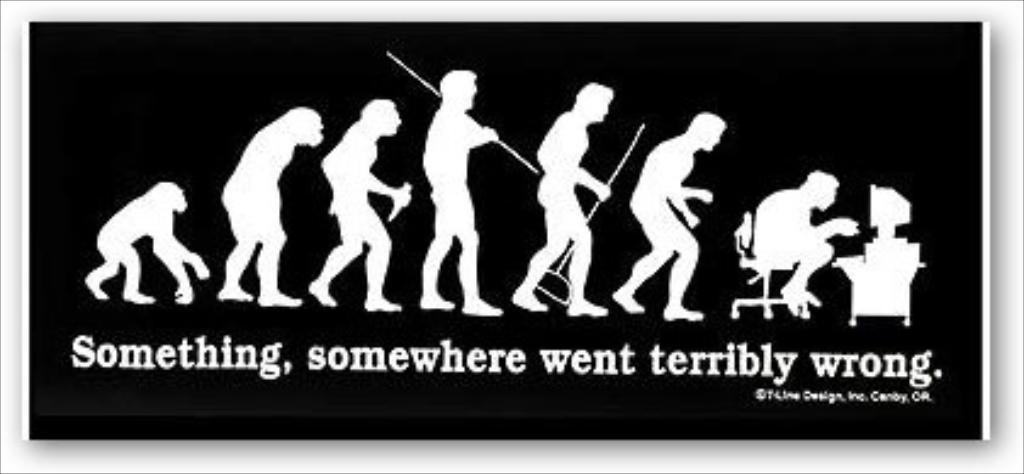<image>
Present a compact description of the photo's key features. An evolution diagram of the man saying "Something went wrong." 